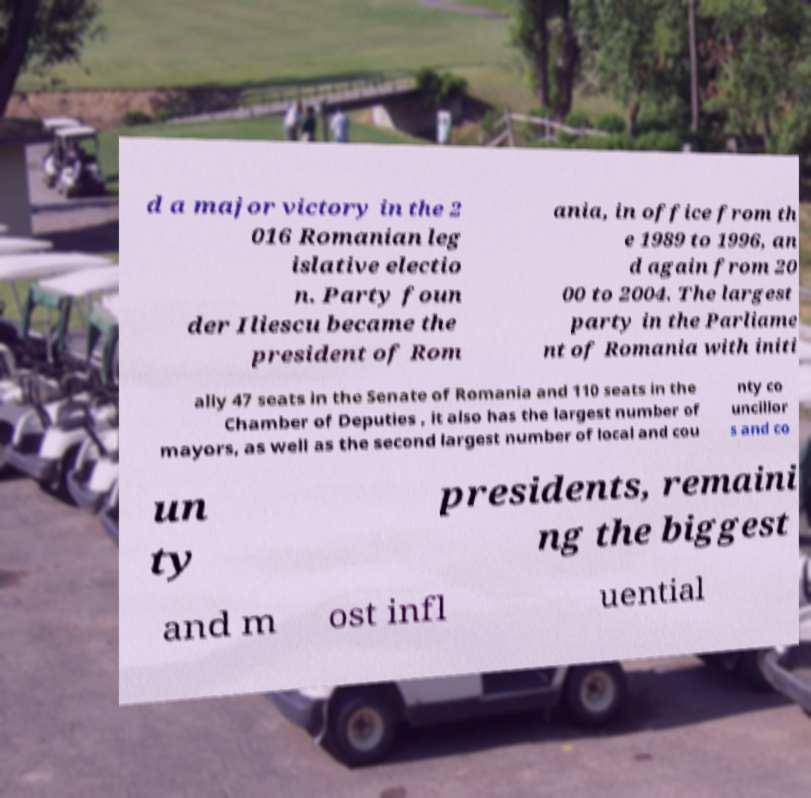For documentation purposes, I need the text within this image transcribed. Could you provide that? d a major victory in the 2 016 Romanian leg islative electio n. Party foun der Iliescu became the president of Rom ania, in office from th e 1989 to 1996, an d again from 20 00 to 2004. The largest party in the Parliame nt of Romania with initi ally 47 seats in the Senate of Romania and 110 seats in the Chamber of Deputies , it also has the largest number of mayors, as well as the second largest number of local and cou nty co uncillor s and co un ty presidents, remaini ng the biggest and m ost infl uential 